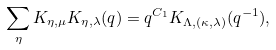Convert formula to latex. <formula><loc_0><loc_0><loc_500><loc_500>\sum _ { \eta } K _ { \eta , \mu } K _ { \eta , \lambda } ( q ) = q ^ { C _ { 1 } } K _ { \Lambda , ( \kappa , \lambda ) } ( q ^ { - 1 } ) ,</formula> 